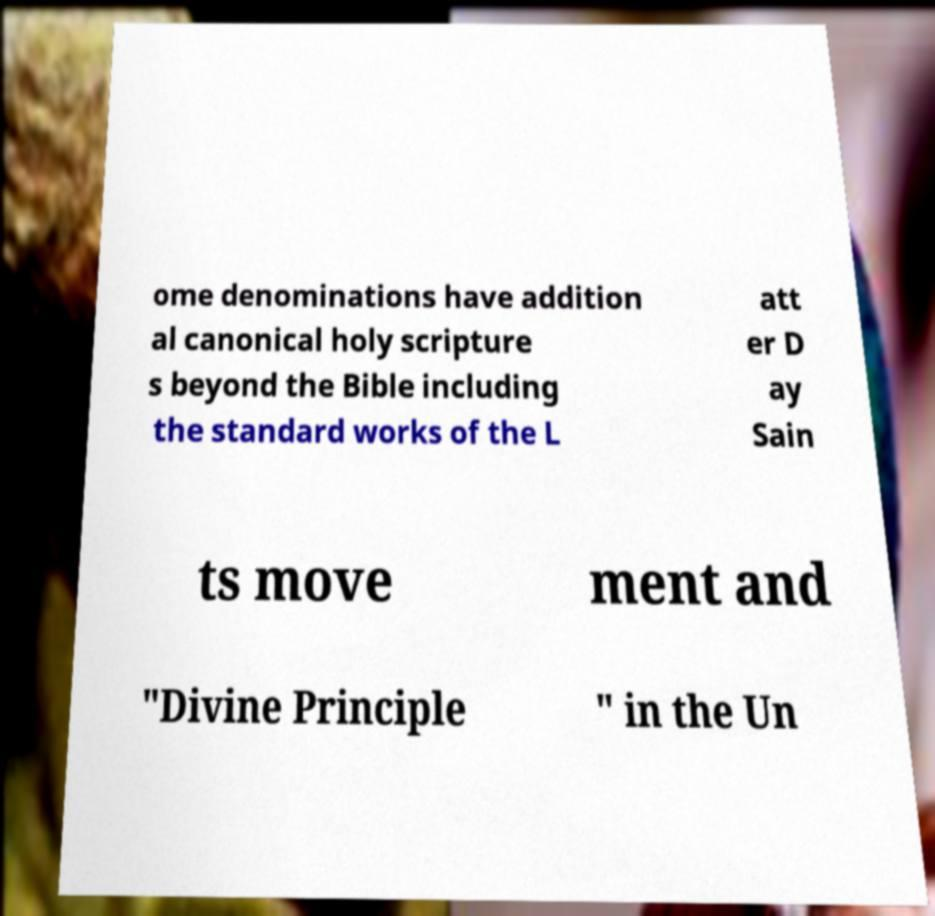Please read and relay the text visible in this image. What does it say? ome denominations have addition al canonical holy scripture s beyond the Bible including the standard works of the L att er D ay Sain ts move ment and "Divine Principle " in the Un 